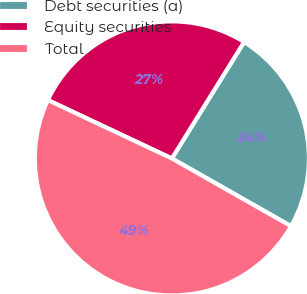<chart> <loc_0><loc_0><loc_500><loc_500><pie_chart><fcel>Debt securities (a)<fcel>Equity securities<fcel>Total<nl><fcel>24.39%<fcel>26.83%<fcel>48.78%<nl></chart> 